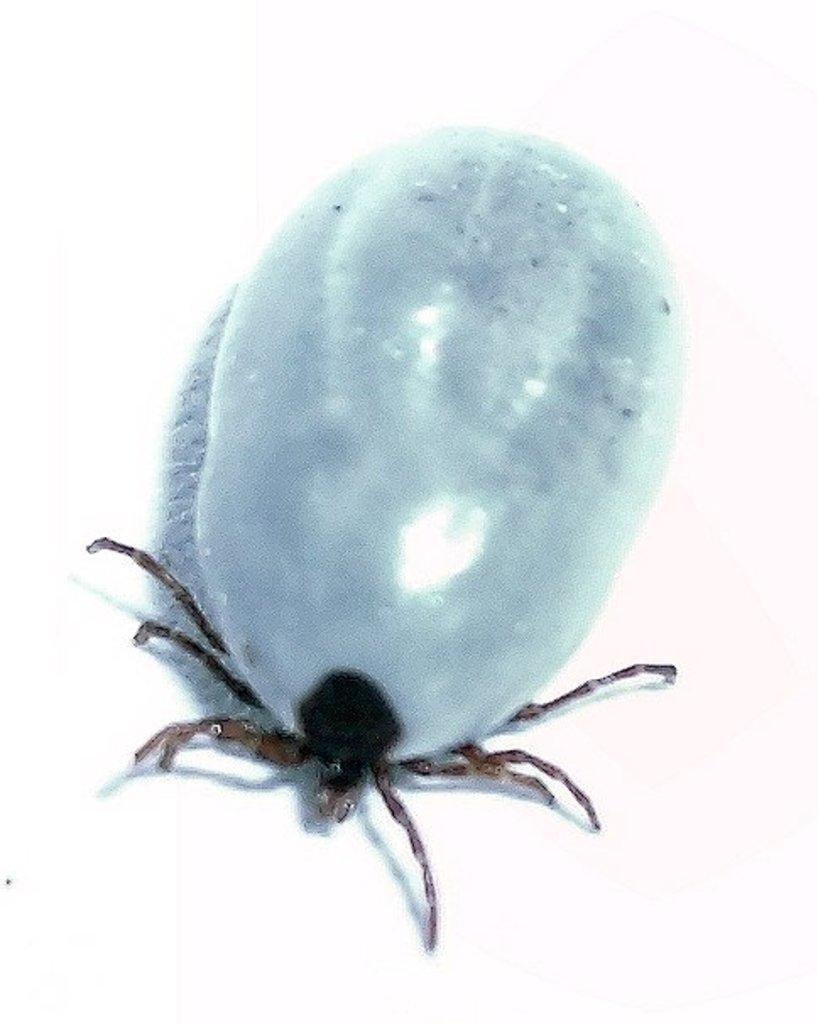What type of creature can be seen in the image? There is an insect in the image. What color is the background of the image? The background of the image is white. What type of shoe is the bear wearing in the image? There is no bear or shoe present in the image; it features an insect and a white background. 